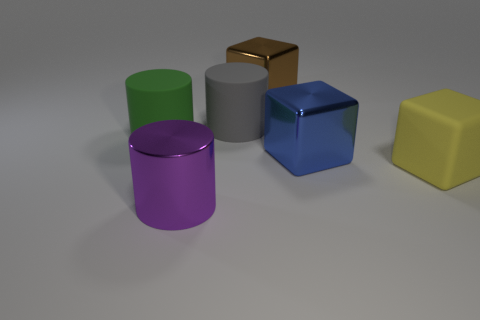Subtract all green rubber cylinders. How many cylinders are left? 2 Subtract 1 cubes. How many cubes are left? 2 Add 2 tiny brown matte things. How many objects exist? 8 Subtract all gray cubes. Subtract all blue spheres. How many cubes are left? 3 Subtract all tiny yellow metal cylinders. Subtract all big metallic objects. How many objects are left? 3 Add 1 large brown shiny things. How many large brown shiny things are left? 2 Add 5 gray rubber cylinders. How many gray rubber cylinders exist? 6 Subtract 1 yellow cubes. How many objects are left? 5 